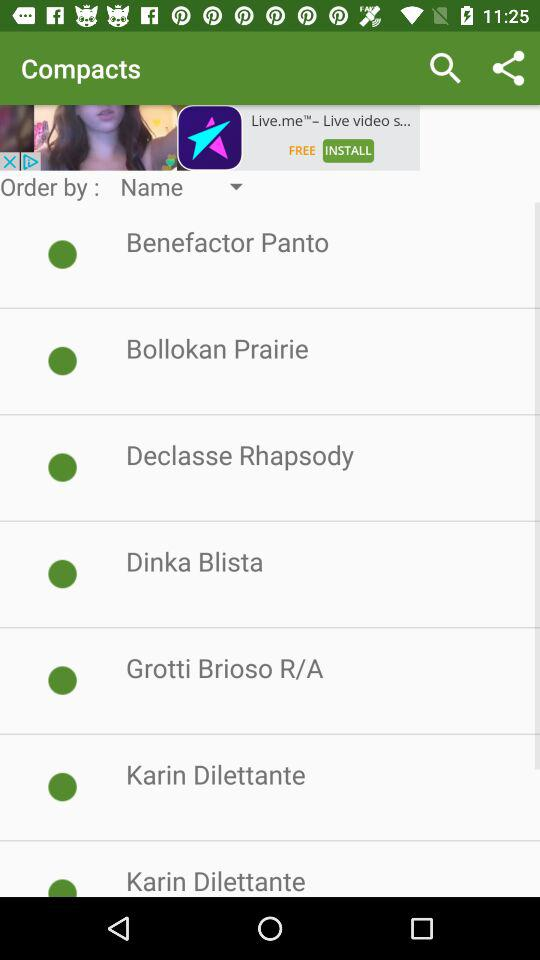What option is selected for "Order by"? The selected option for "Order by" is "Name". 